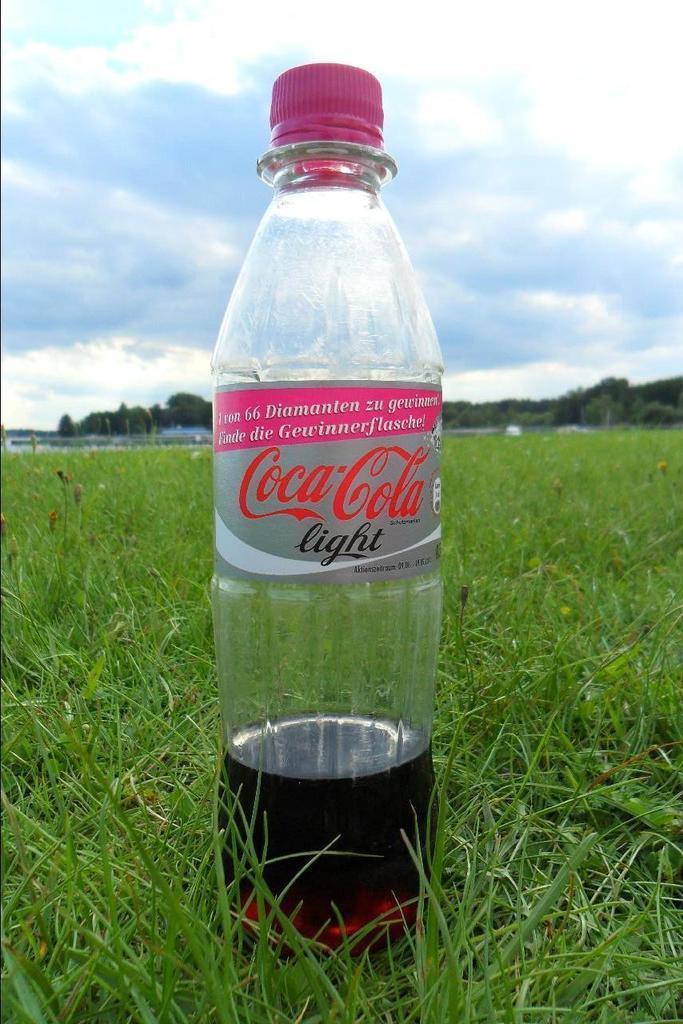Please provide a concise description of this image. In this image there is a bottle having a drink inside it is having a pink colour cap. Bottle is placed on a grassy land. Background there are few trees and sky with some clouds. 